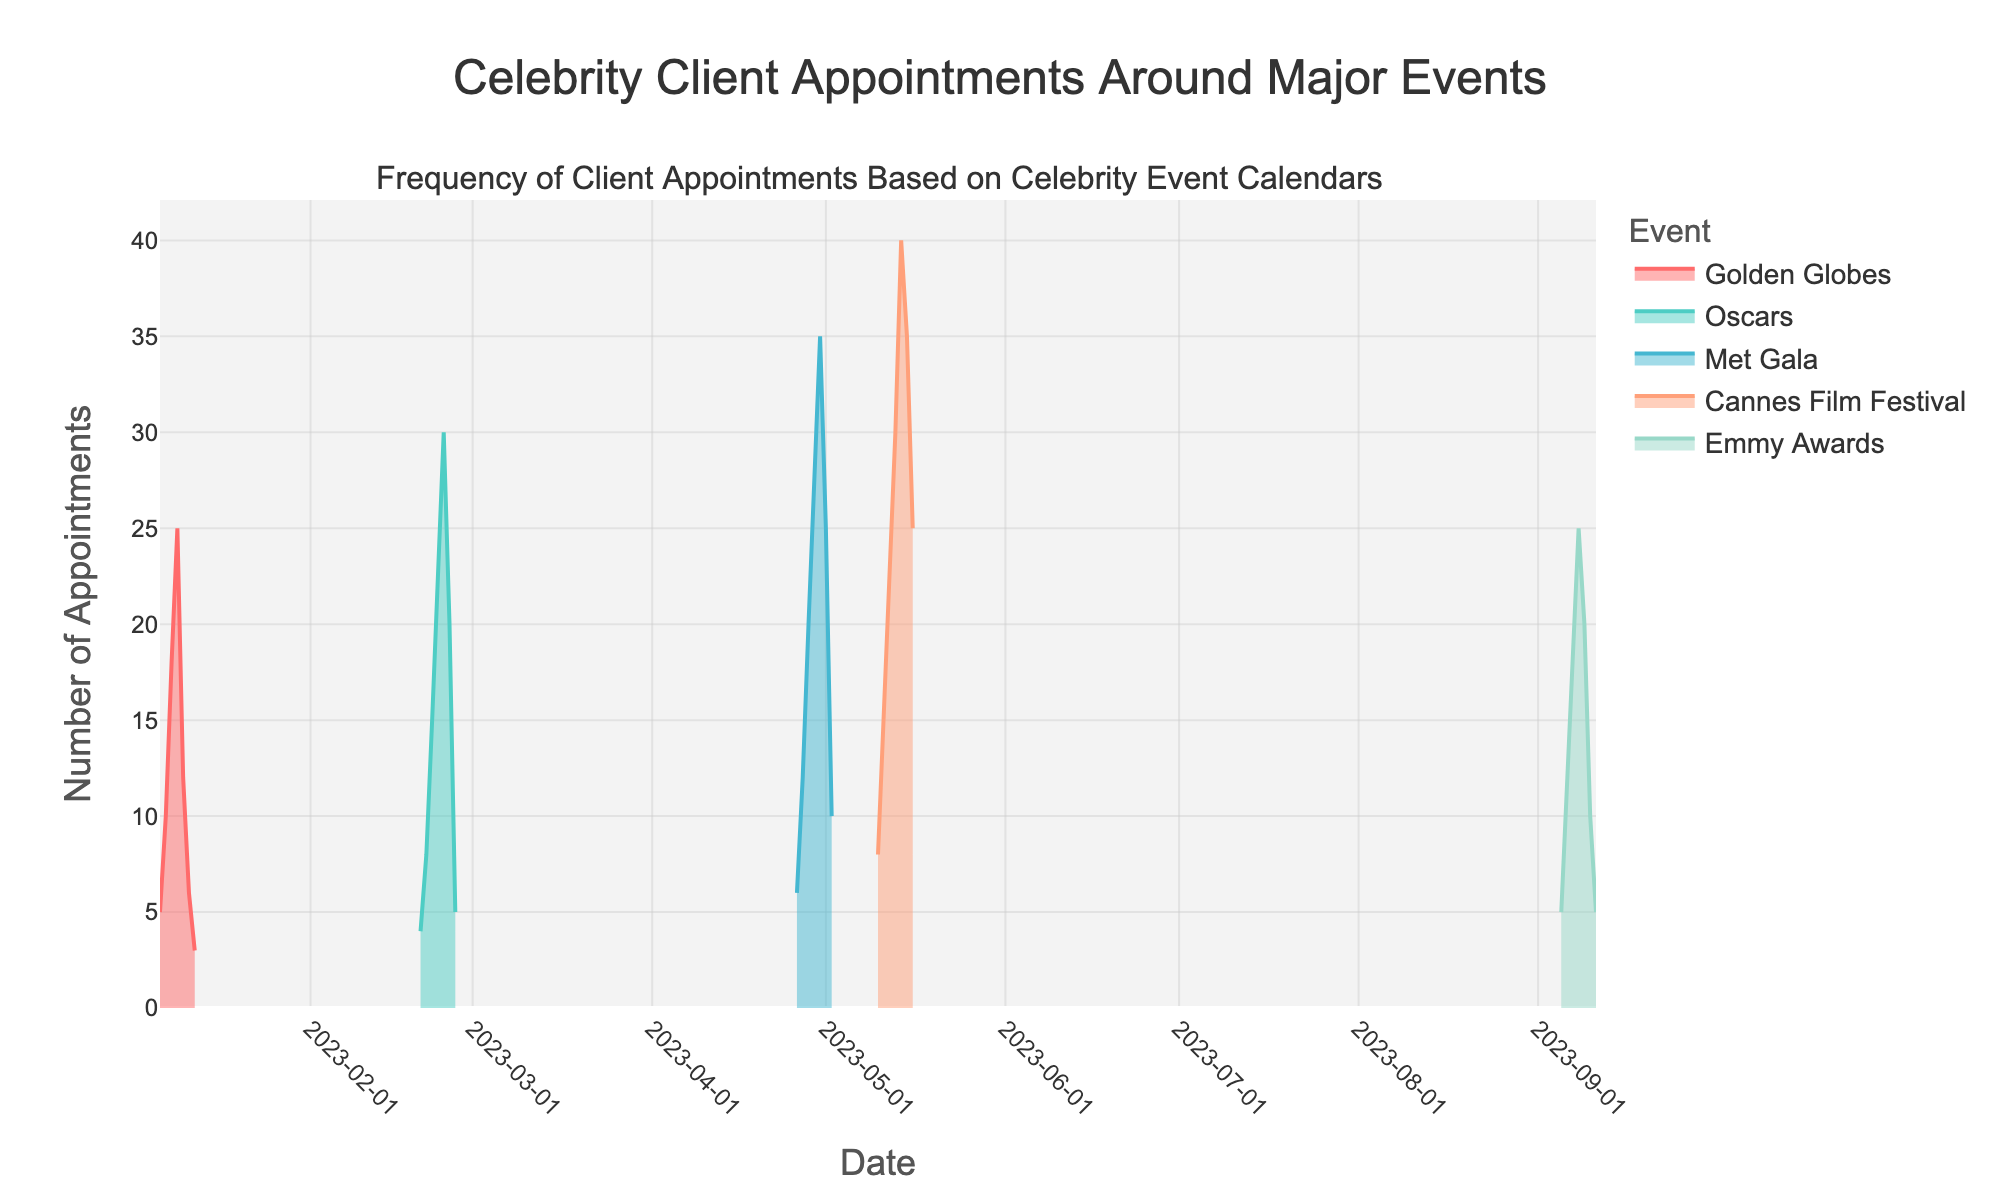what is the overall trend in the frequency of appointments during the Golden Globes? The frequency of appointments starts with a low number, increases to a peak, and then gradually decreases. Specifically, it starts at 5 on January 6th, rises to a peak of 25 on January 9th, and then falls back down to 3 by January 12th.
Answer: The trend starts low, peaks, then decreases When is the highest frequency of appointments during the Oscars? The highest frequency occurs on February 24th. By looking at the step area chart, we see the peak value is reached on this date, marked by the tallest filled area.
Answer: February 24th How does the frequency of appointments during the Met Gala compare to the Golden Globes? The Met Gala appointments start at 6 and peak at 35 on April 30th before decreasing, while the Golden Globes start at 5, peak at 25 on January 9th, and fall to 3. The Met Gala reaches a higher peak compared to the Golden Globes.
Answer: Met Gala has a higher peak Which event has the steepest increase in the frequency of appointments? By examining the slope (rate of increase), the Cannes Film Festival has the steepest increase, jumping from 8 on May 10th to 40 on May 14th. No other events have such a sharp increase over a similar time frame in the step area chart.
Answer: Cannes Film Festival What is the total increase in appointments from the first to the last day of the Emmy Awards? The frequency starts at 5 on September 5th and ends at 5 on September 11th. The total increase is 0 since the start and end values are both 5.
Answer: 0 On which days do significant drops in appointments occur? Significant drops are observable in the charts for the Golden Globes on January 10th (from 25 to 12), the Oscars on February 26th (from 20 to 5), the Met Gala on May 2nd (from 25 to 10), and the Cannes Film Festival on May 15th (from 40 to 35).
Answer: January 10th, February 26th, May 2nd, May 15th What is the average frequency of appointments during the Cannes Film Festival? The values are 8, 15, 22, 30, 40, 35, and 25. Summing them gives 175, and there are 7 days, so the average is 175/7.
Answer: 25 Which event shows the most consistent frequency change over the dates? The Golden Globes show the most consistent change, with increments happening steadily until the peak and then decreasing in a symmetrical manner. The other events exhibit more variability.
Answer: Golden Globes 